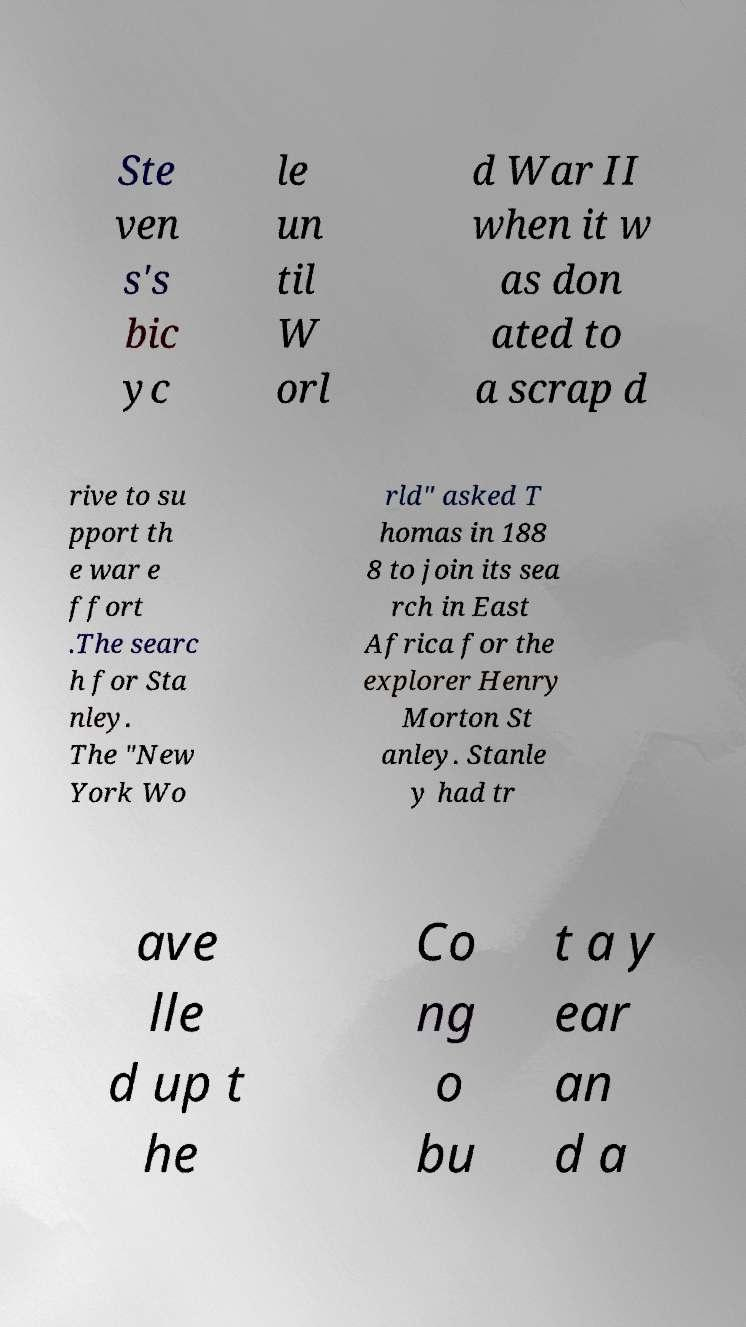Can you read and provide the text displayed in the image?This photo seems to have some interesting text. Can you extract and type it out for me? Ste ven s's bic yc le un til W orl d War II when it w as don ated to a scrap d rive to su pport th e war e ffort .The searc h for Sta nley. The "New York Wo rld" asked T homas in 188 8 to join its sea rch in East Africa for the explorer Henry Morton St anley. Stanle y had tr ave lle d up t he Co ng o bu t a y ear an d a 